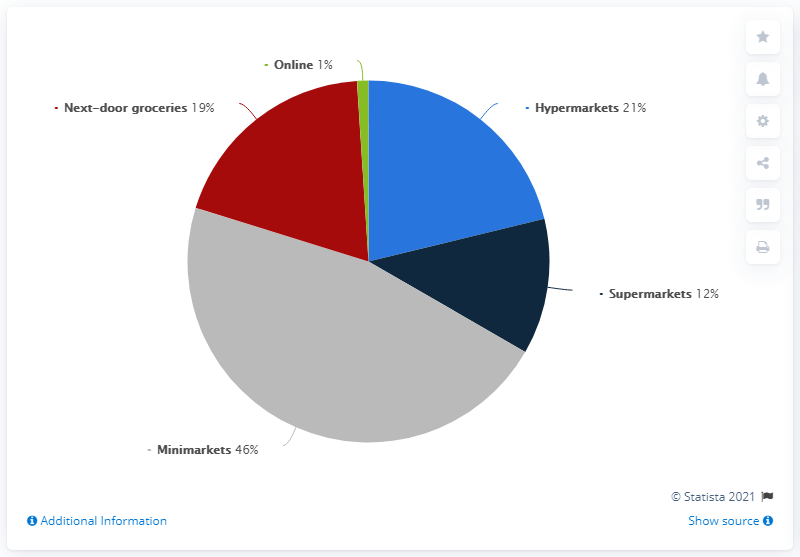List a handful of essential elements in this visual. What is the total of the markets? 79... (is equal to) a certain value. It is reported that some individuals have stated that they have accessed the internet. 